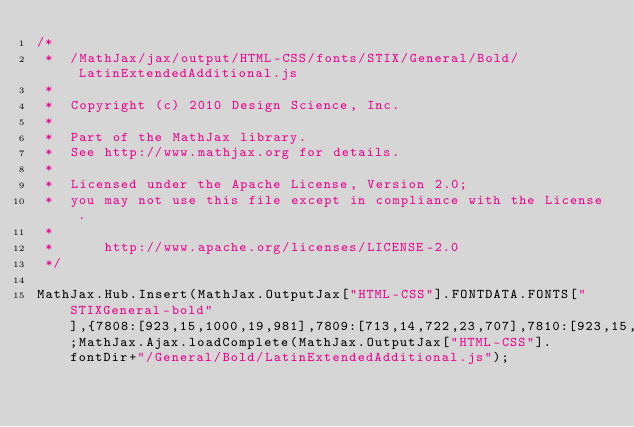Convert code to text. <code><loc_0><loc_0><loc_500><loc_500><_JavaScript_>/*
 *  /MathJax/jax/output/HTML-CSS/fonts/STIX/General/Bold/LatinExtendedAdditional.js
 *  
 *  Copyright (c) 2010 Design Science, Inc.
 *
 *  Part of the MathJax library.
 *  See http://www.mathjax.org for details.
 * 
 *  Licensed under the Apache License, Version 2.0;
 *  you may not use this file except in compliance with the License.
 *
 *      http://www.apache.org/licenses/LICENSE-2.0
 */

MathJax.Hub.Insert(MathJax.OutputJax["HTML-CSS"].FONTDATA.FONTS["STIXGeneral-bold"],{7808:[923,15,1000,19,981],7809:[713,14,722,23,707],7810:[923,15,1000,19,981],7811:[713,14,722,23,707],7812:[876,15,1000,19,981],7813:[666,14,722,23,707],7922:[923,0,722,15,699],7923:[713,205,500,16,482]});MathJax.Ajax.loadComplete(MathJax.OutputJax["HTML-CSS"].fontDir+"/General/Bold/LatinExtendedAdditional.js");

</code> 